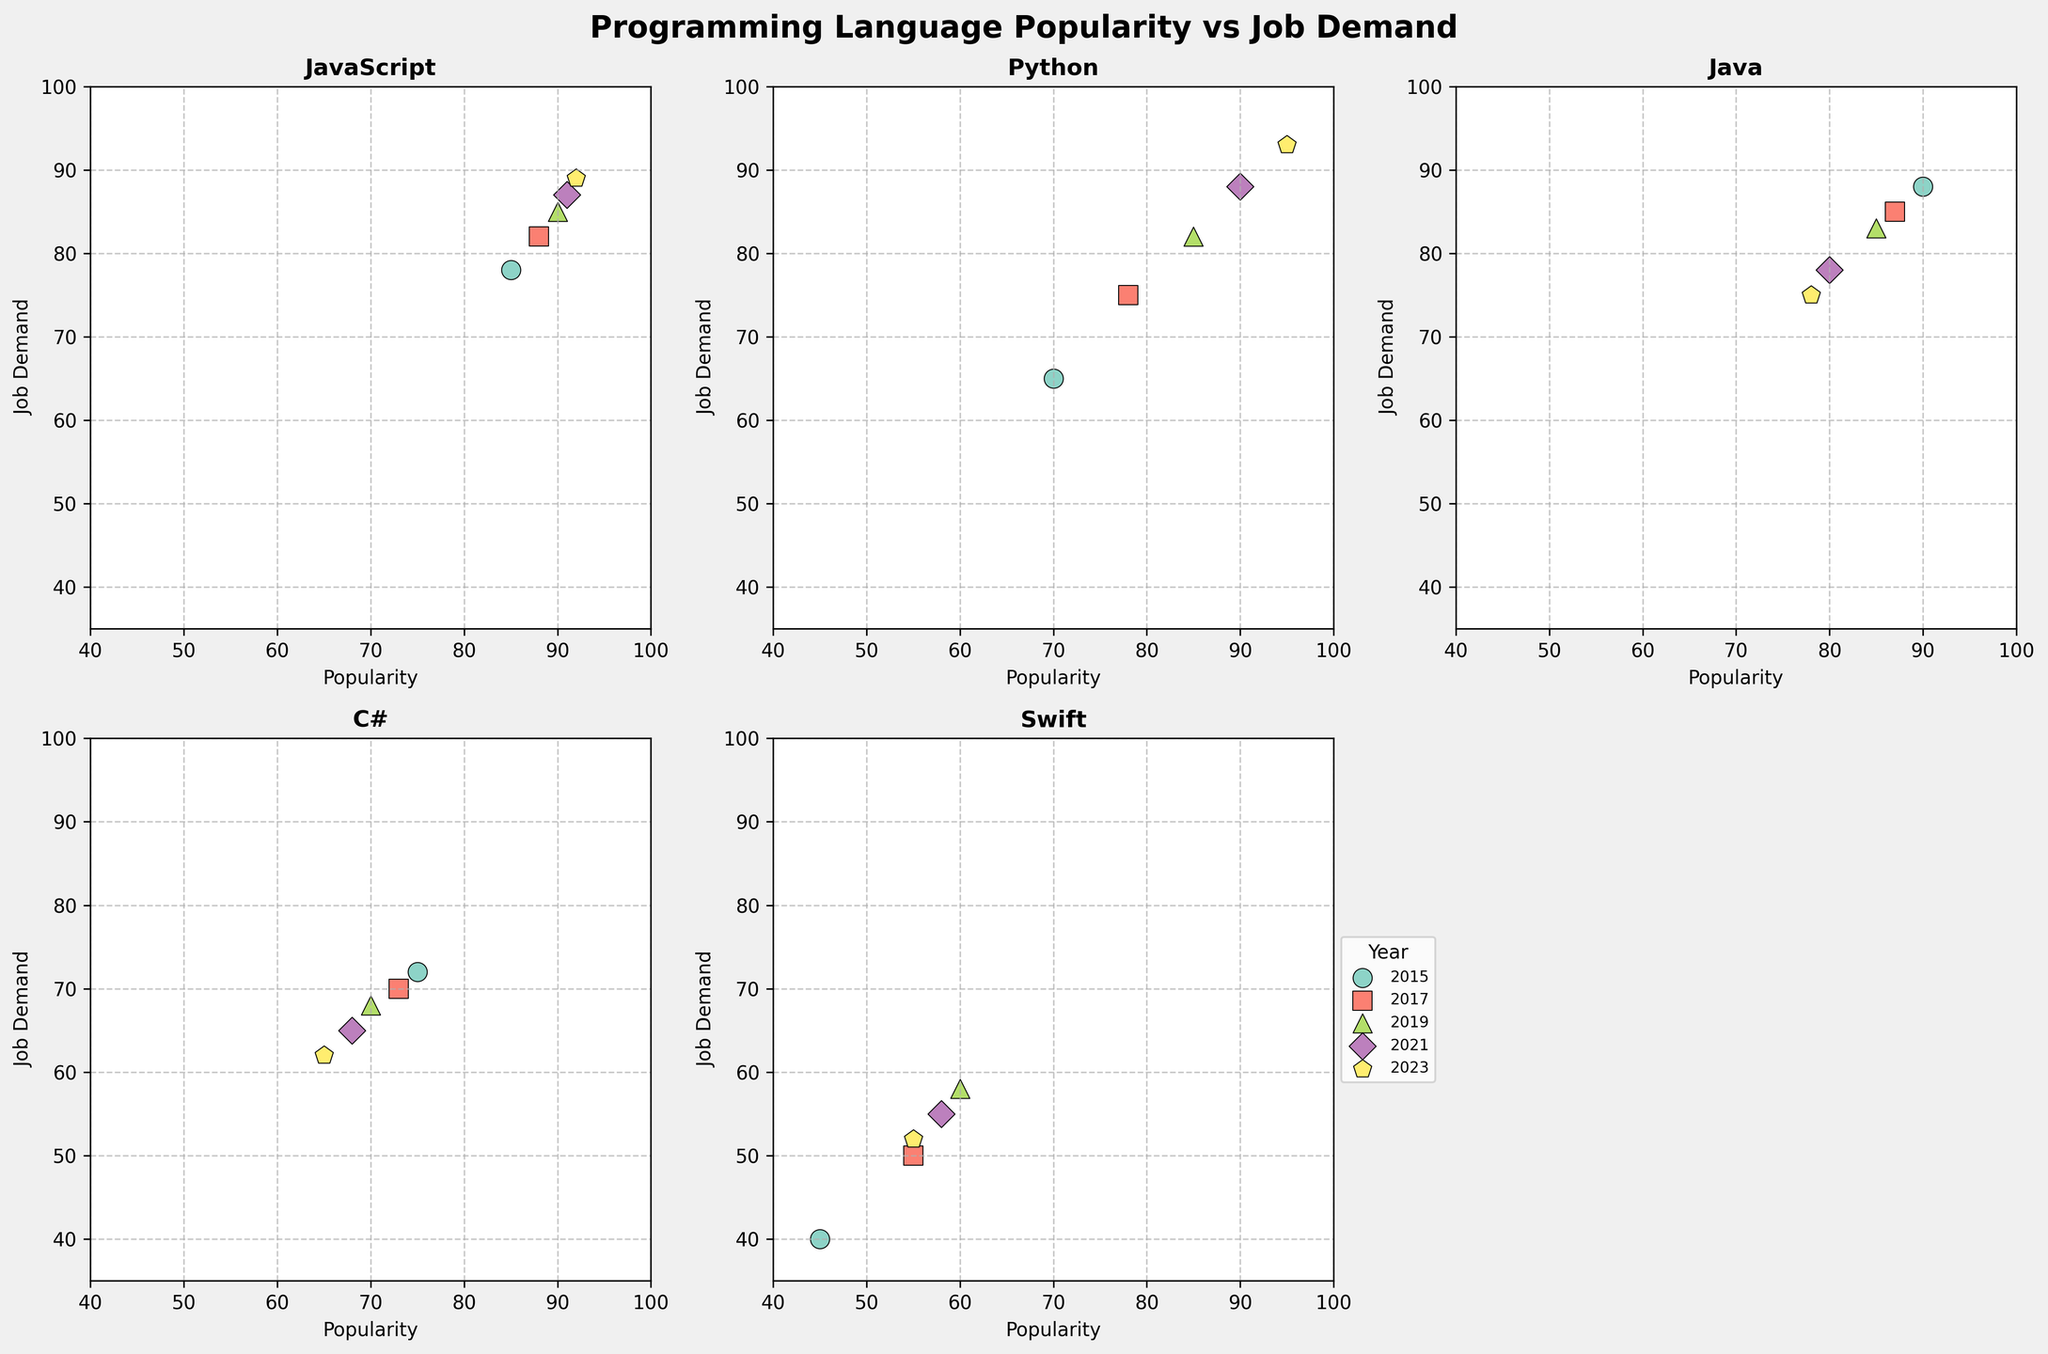Which language has the highest popularity in 2023? To find the language with the highest popularity in 2023, we locate the 2023 data points and compare the popularity scores. Python has the highest popularity score of 95.
Answer: Python What is the general trend of Python's job demand from 2015 to 2023? Observing the scatter plot for Python, we see the job demand data points increase over the years. Starting from 65 in 2015, it rises to 93 in 2023.
Answer: Increasing Which language shows a decline in both popularity and job demand from 2015 to 2023? By comparing the data points from 2015 to 2023 for each language, we notice that Java shows a decline in both popularity (from 90 to 78) and job demand (from 88 to 75).
Answer: Java Among JavaScript, Python, and Swift, which one had the closest popularity and job demand in 2019? We need to compare the popularity and job demand for each language in 2019: JavaScript (90, 85), Python (85, 82), and Swift (60, 58). Swift has the smallest difference (2).
Answer: Swift In which year do C# and Java have the closest job demand? Looking at the job demand data points for each year, we see that in 2017, C# (70) and Java (85) have the closest job demands with a difference of 2.
Answer: 2015 How does Swift's popularity in 2023 compare to its popularity in 2015? By comparing the popularity data points for Swift in 2023 (55) and 2015 (45), we see that there is an increase of 10 points.
Answer: Increased by 10 points What relationship can be observed between the popularity and job demand for JavaScript over the years? Examining the scatter plots for JavaScript across the years shows a roughly positive correlation; as popularity increases, so does job demand, with both being high throughout the period.
Answer: Positive correlation Which language had the least increase in job demand from 2015 to 2023? Calculating the job demand increase for each language over the years: JavaScript (11), Python (28), Java (-13), C# (-10), Swift (12). Java had the least increase, in fact, a decrease.
Answer: Java How did the relationship between popularity and job demand change for C# from 2015 to 2023? Observing C#'s data points, popularity and job demand both show a negative trend, decreasing from 75 to 65 and from 72 to 62, respectively, indicating a simultaneous decline.
Answer: Both declined What can be inferred about the job demand trend for JavaScript from 2019 to 2023? By observing the 2019 (85) and 2023 (89) job demand points for JavaScript, we infer an increasing trend in job demand over the period.
Answer: Increasing 